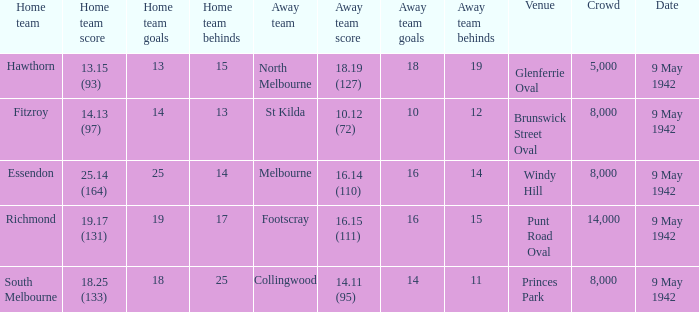How many people attended the game with the home team scoring 18.25 (133)? 1.0. Parse the table in full. {'header': ['Home team', 'Home team score', 'Home team goals', 'Home team behinds', 'Away team', 'Away team score', 'Away team goals', 'Away team behinds', 'Venue', 'Crowd', 'Date'], 'rows': [['Hawthorn', '13.15 (93)', '13', '15', 'North Melbourne', '18.19 (127)', '18', '19', 'Glenferrie Oval', '5,000', '9 May 1942'], ['Fitzroy', '14.13 (97)', '14', '13', 'St Kilda', '10.12 (72)', '10', '12', 'Brunswick Street Oval', '8,000', '9 May 1942'], ['Essendon', '25.14 (164)', '25', '14', 'Melbourne', '16.14 (110)', '16', '14', 'Windy Hill', '8,000', '9 May 1942'], ['Richmond', '19.17 (131)', '19', '17', 'Footscray', '16.15 (111)', '16', '15', 'Punt Road Oval', '14,000', '9 May 1942'], ['South Melbourne', '18.25 (133)', '18', '25', 'Collingwood', '14.11 (95)', '14', '11', 'Princes Park', '8,000', '9 May 1942']]} 